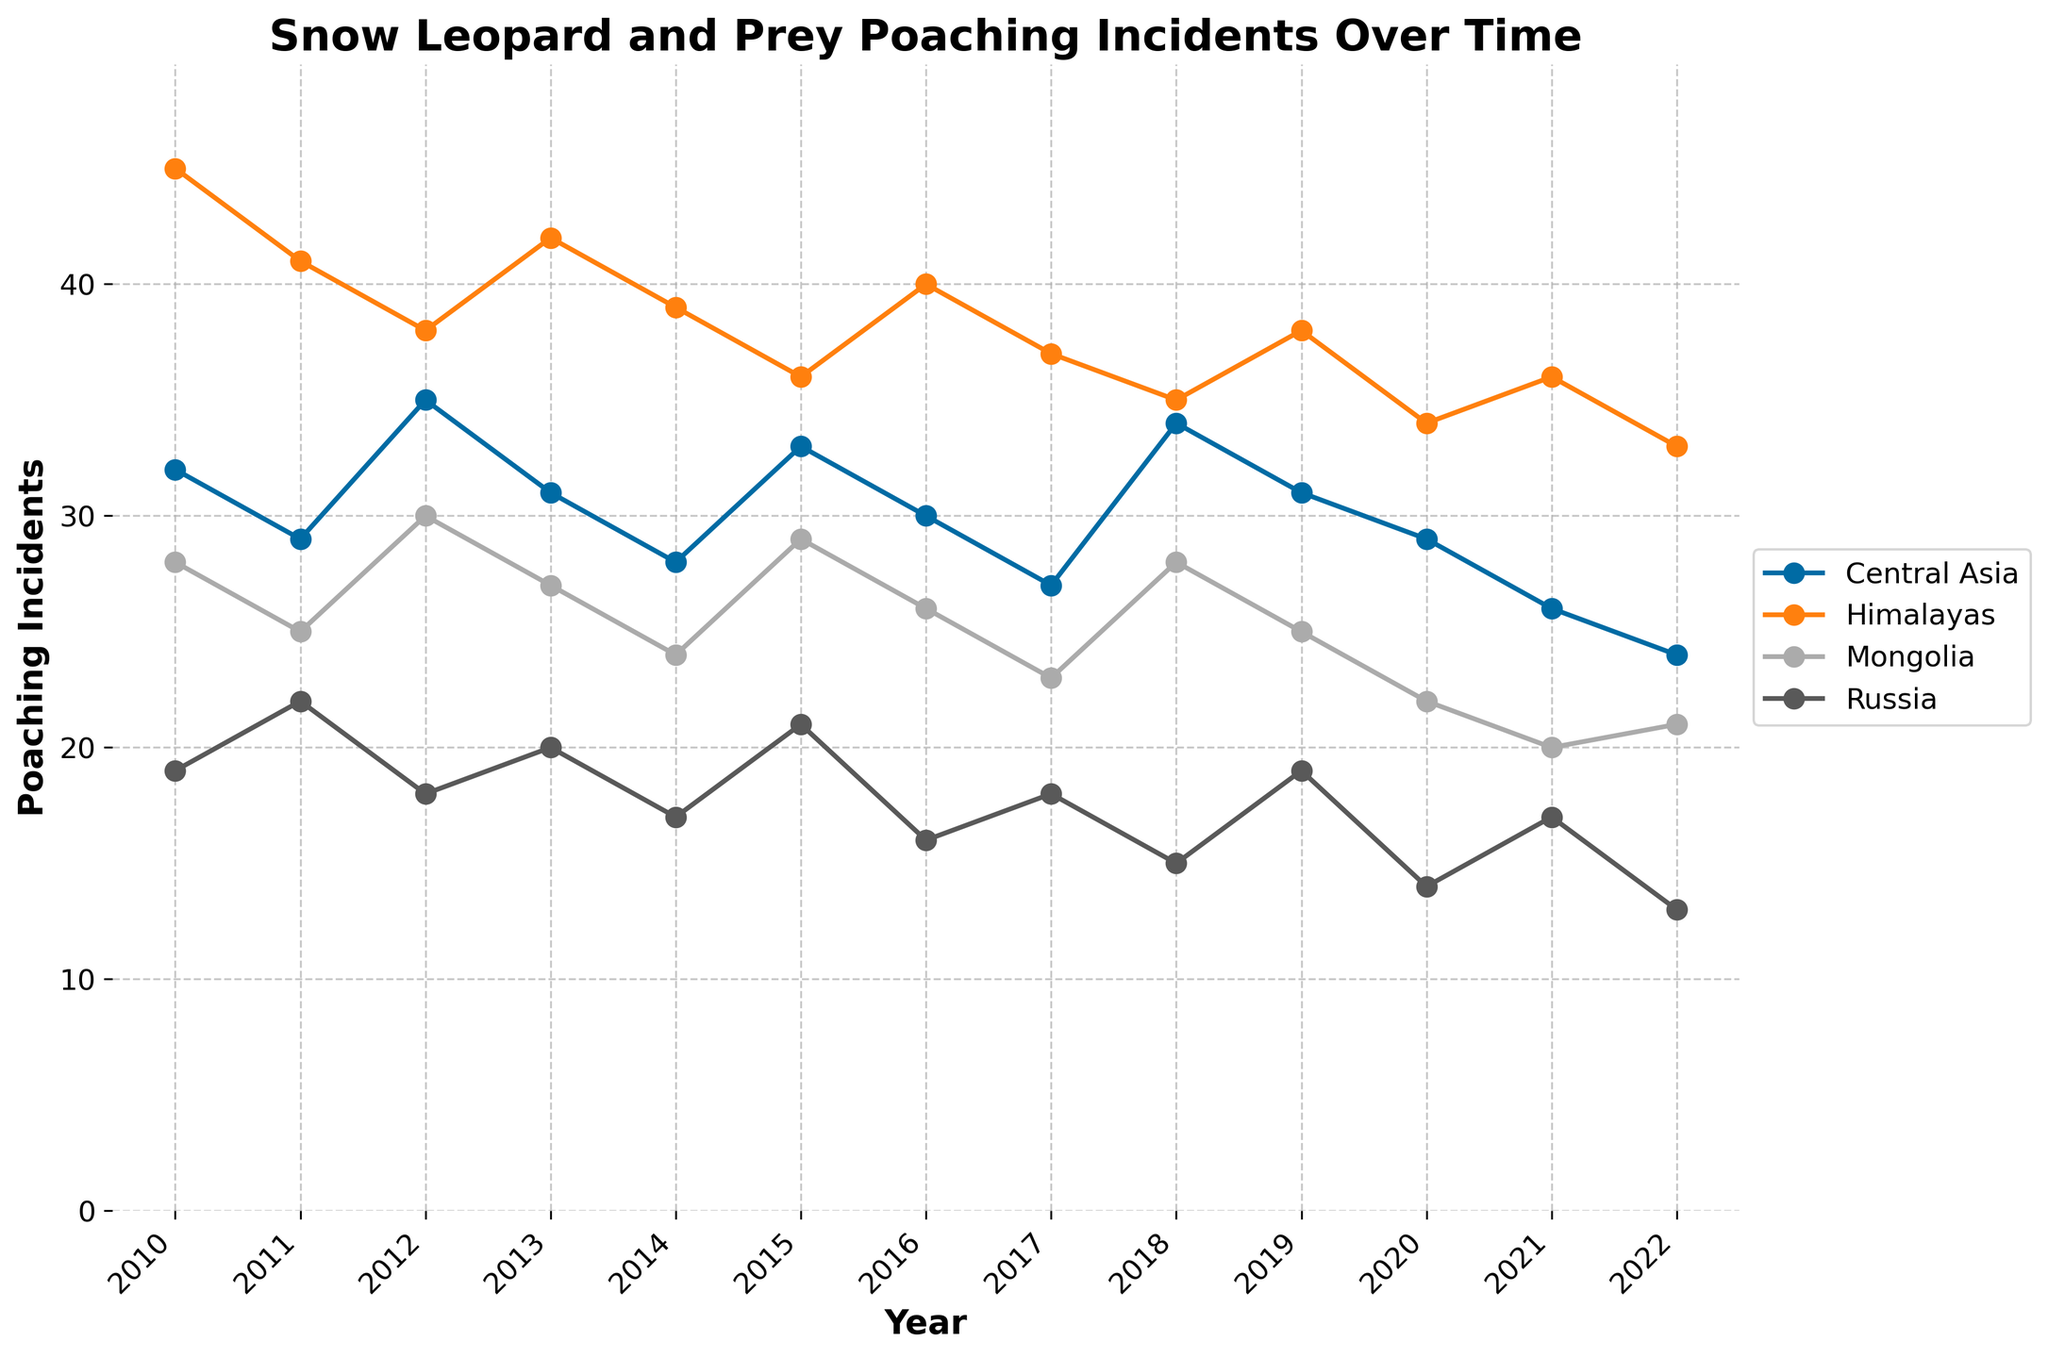What year had the highest number of poaching incidents in the Himalayas? First, look at the line representing the Himalayas. Identify the peak point on the Himalayas line. The highest number of poaching incidents occurs in 2010 with 45 incidents.
Answer: 2010 Which region had the lowest number of poaching incidents in 2022? Observe each line at the year 2022 and compare the values. The value for Central Asia is 24, Himalayas 33, Mongolia 21, and Russia 13. The lowest number is for Russia.
Answer: Russia In which year did Central Asia and Mongolia have the same number of poaching incidents? Look for intersecting points of the lines representing Central Asia and Mongolia. They intersect at the year 2018 with both reporting 34 incidents.
Answer: 2018 What is the difference in poaching incidents between Central Asia and Russia in 2011? Find the data points for the year 2011: Central Asia has 29 incidents and Russia has 22 incidents. The difference is 29 - 22 = 7 incidents.
Answer: 7 Which year had the steepest decline in poaching incidents in the Himalayas and by how much did it decline? Identify the year-to-year changes in the Himalayas line. Notice the largest drop from 45 incidents in 2010 to 41 in 2011. The decline is 45 - 41 = 4 incidents.
Answer: 2011, 4 incidents What is the average number of poaching incidents in Mongolia from 2010 to 2022? Sum up the poaching incidents from 2010 to 2022: 28 + 25 + 30 + 27 + 24 + 29 + 26 + 23 + 28 + 25 + 22 + 20 + 21 = 328. Divide by the number of years, 328 / 13 = 25.23 (approx).
Answer: 25.23 Compare the overall trend in poaching incidents for Central Asia and Russia from 2010 to 2022. Which region shows a larger decrease? Identify the change from 2010 to 2022 for each region: Central Asia starts at 32 and ends at 24 (a decrease of 8), Russia starts at 19 and ends at 13 (a decrease of 6). Central Asia shows a larger decrease.
Answer: Central Asia Which region shows the most consistent number of poaching incidents over the years? Look at the smoothness and fluctuation of lines. The Mongolia line shows less variation and has smaller changes.
Answer: Mongolia 